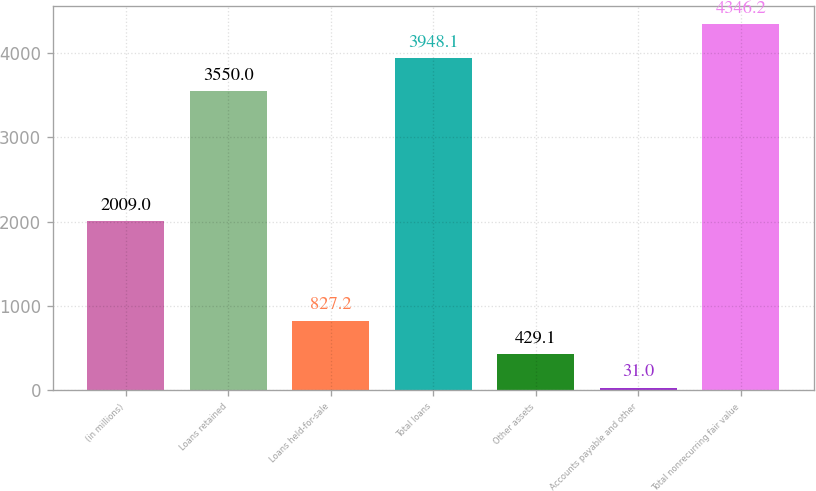Convert chart. <chart><loc_0><loc_0><loc_500><loc_500><bar_chart><fcel>(in millions)<fcel>Loans retained<fcel>Loans held-for-sale<fcel>Total loans<fcel>Other assets<fcel>Accounts payable and other<fcel>Total nonrecurring fair value<nl><fcel>2009<fcel>3550<fcel>827.2<fcel>3948.1<fcel>429.1<fcel>31<fcel>4346.2<nl></chart> 